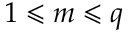<formula> <loc_0><loc_0><loc_500><loc_500>1 \leqslant m \leqslant q</formula> 